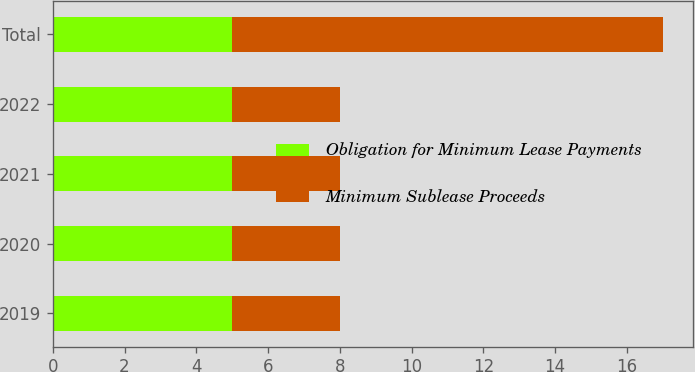Convert chart. <chart><loc_0><loc_0><loc_500><loc_500><stacked_bar_chart><ecel><fcel>2019<fcel>2020<fcel>2021<fcel>2022<fcel>Total<nl><fcel>Obligation for Minimum Lease Payments<fcel>5<fcel>5<fcel>5<fcel>5<fcel>5<nl><fcel>Minimum Sublease Proceeds<fcel>3<fcel>3<fcel>3<fcel>3<fcel>12<nl></chart> 